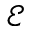<formula> <loc_0><loc_0><loc_500><loc_500>\mathcal { E }</formula> 